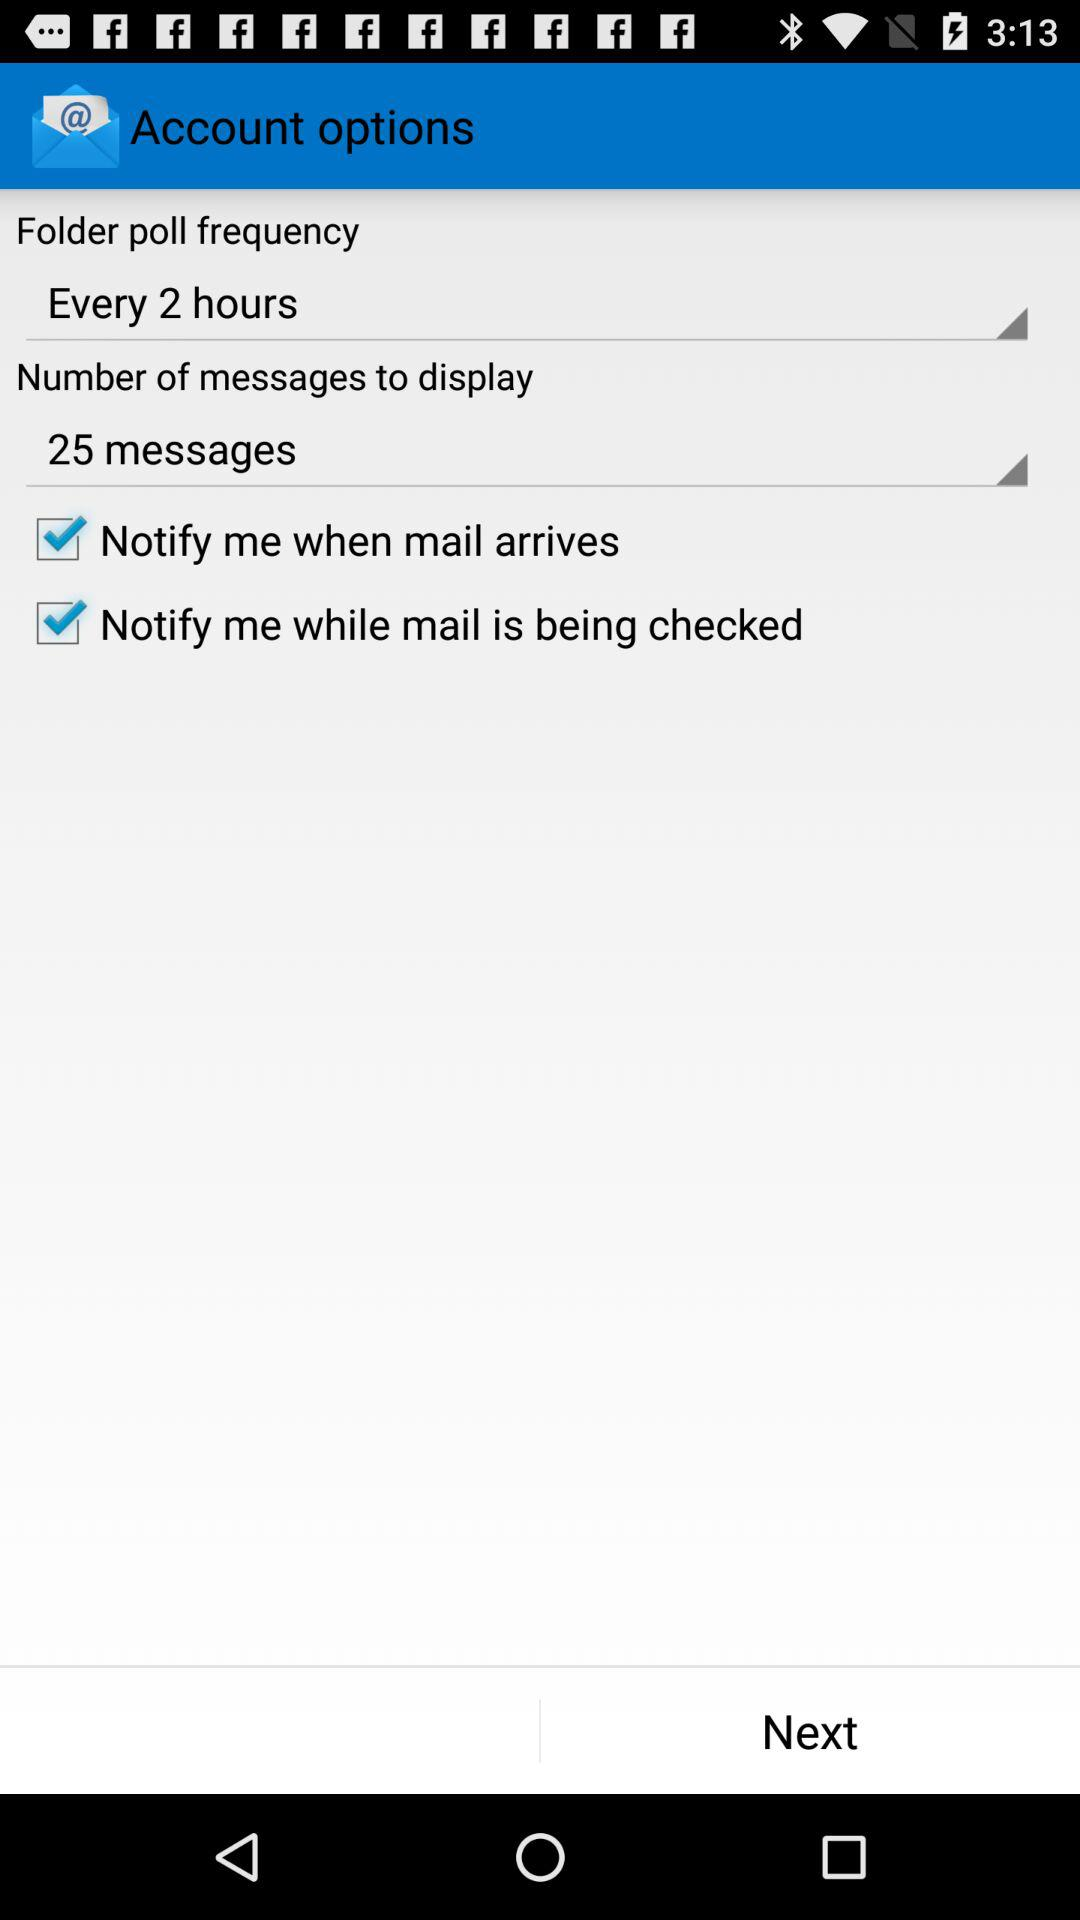What is the folder poll frequency? The folder poll frequency is "Every 2 hours". 